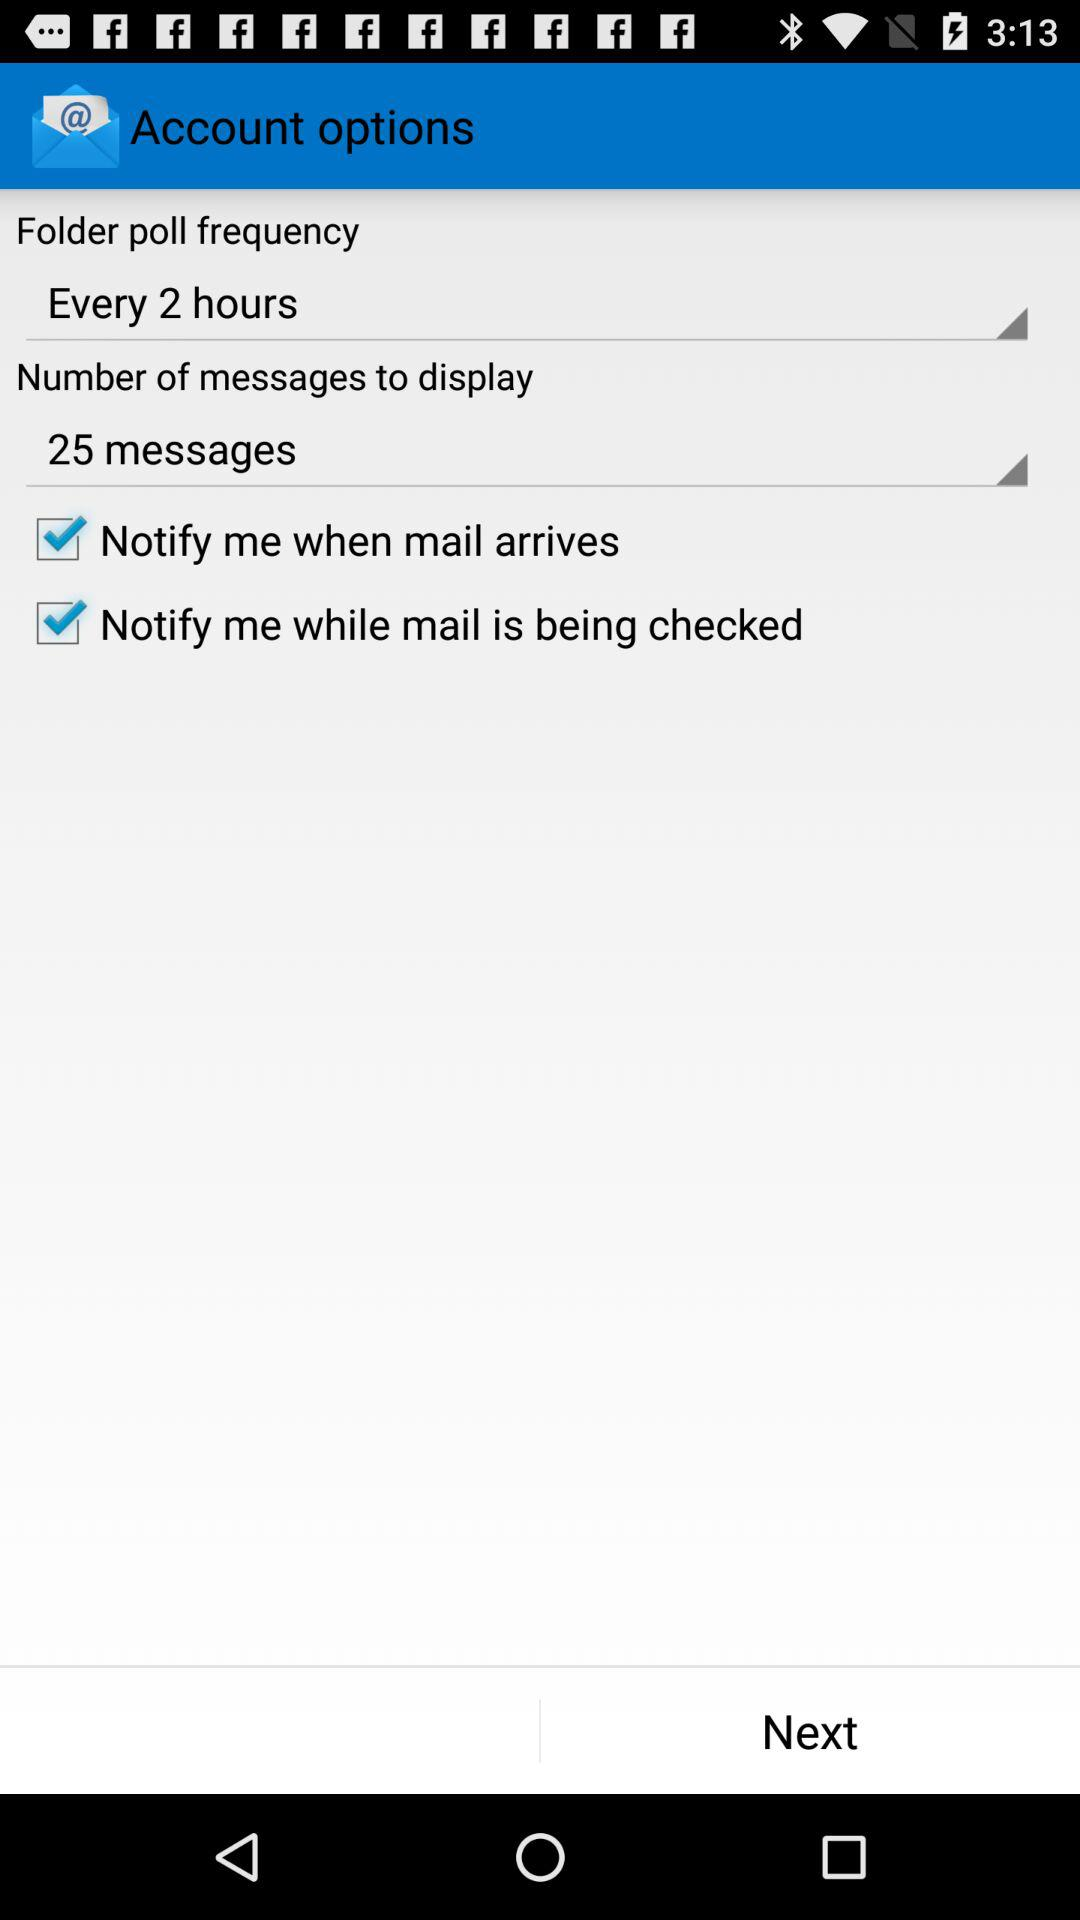What is the folder poll frequency? The folder poll frequency is "Every 2 hours". 